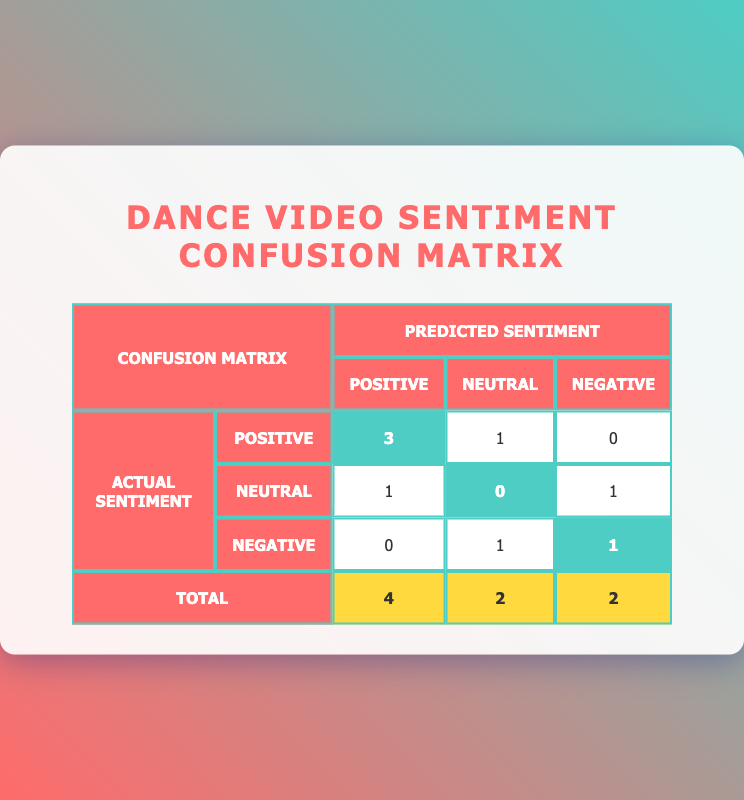What is the number of videos with a positive actual sentiment? Looking at the "Actual Sentiment" row for "Positive," we can see that the value is 3. This means there are 3 videos with a "Positive" actual sentiment.
Answer: 3 How many dance videos were predicted to have a neutral sentiment? From the table, if we sum up the values in the "Neutral" column, we find 1 (from the "Positive" actual sentiment row) + 0 (from the "Neutral" actual sentiment row) + 1 (from the "Negative" actual sentiment row) = 2. Therefore, there are 2 dance videos predicted to have a neutral sentiment.
Answer: 2 Is there any dance video that received a negative prediction when the actual sentiment was positive? Checking the table, the only instance where the actual sentiment was positive is in the "Positive" row, where there is no corresponding "Negative" in the predictions. Hence, there are no videos predicted as negative with the actual positive sentiment.
Answer: No What is the percentage of accurately predicted positive sentiments among all predicted positive sentiments? The accurately predicted positive sentiments are 3 (from the actual positive row) out of a total of 4 predicted positives (3 + 1 + 0). Therefore, the percentage is (3/4) * 100 = 75%.
Answer: 75 percent How many videos were incorrectly predicted as negative? Incorrectly predicted negative videos would include videos that had an actual positive sentiment but were predicted as negative. Looking at the table, there are no such instances, so the count is 0.
Answer: 0 What is the total number of videos analyzed in this sentiment analysis? To find the total number of videos, we can sum the total values from the last row of the table: 4 (Positive) + 2 (Neutral) + 2 (Negative) = 8. Thus, the total number of videos analyzed is 8.
Answer: 8 How many dance videos had a negative actual sentiment? Referring to the "Actual Sentiment" row for "Negative," we find the number of videos is 1, indicating that there is only 1 video with a negative actual sentiment.
Answer: 1 What combination predicts neutral sentiments when the actual sentiment is negative? Observing the row for "Negative" actual sentiment, we see that it was predicted as neutral in 1 occurrence, indicating there is one such combination where the actual negative sentiment was predicted as neutral.
Answer: 1 